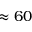Convert formula to latex. <formula><loc_0><loc_0><loc_500><loc_500>\approx 6 0</formula> 